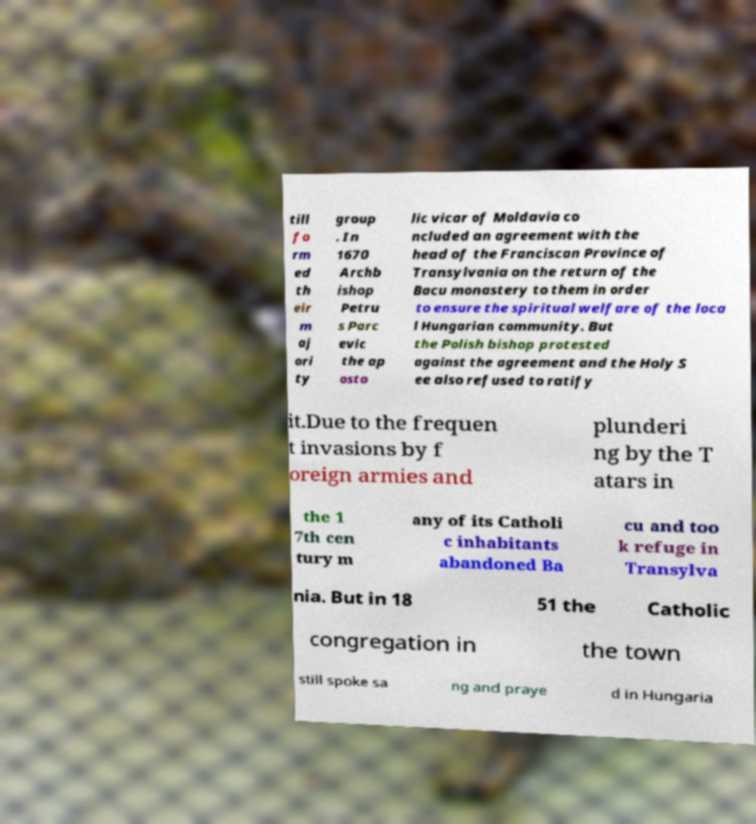Could you assist in decoding the text presented in this image and type it out clearly? till fo rm ed th eir m aj ori ty group . In 1670 Archb ishop Petru s Parc evic the ap osto lic vicar of Moldavia co ncluded an agreement with the head of the Franciscan Province of Transylvania on the return of the Bacu monastery to them in order to ensure the spiritual welfare of the loca l Hungarian community. But the Polish bishop protested against the agreement and the Holy S ee also refused to ratify it.Due to the frequen t invasions by f oreign armies and plunderi ng by the T atars in the 1 7th cen tury m any of its Catholi c inhabitants abandoned Ba cu and too k refuge in Transylva nia. But in 18 51 the Catholic congregation in the town still spoke sa ng and praye d in Hungaria 